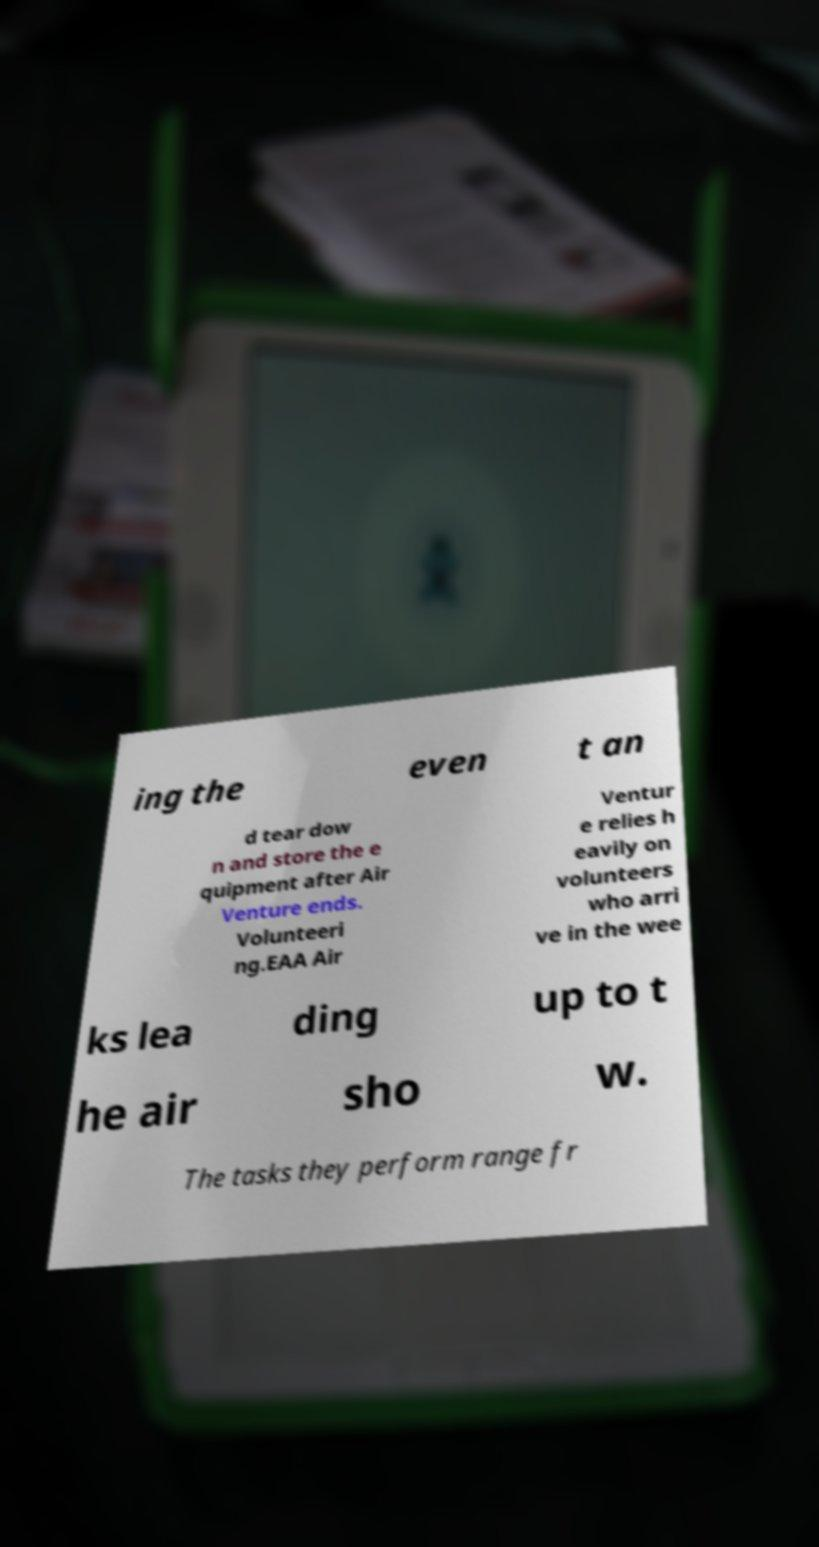I need the written content from this picture converted into text. Can you do that? ing the even t an d tear dow n and store the e quipment after Air Venture ends. Volunteeri ng.EAA Air Ventur e relies h eavily on volunteers who arri ve in the wee ks lea ding up to t he air sho w. The tasks they perform range fr 